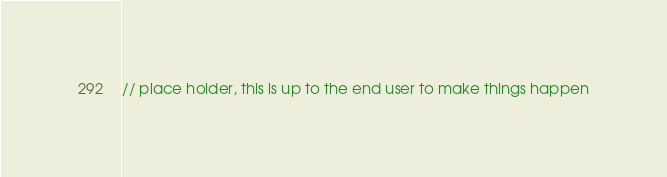Convert code to text. <code><loc_0><loc_0><loc_500><loc_500><_JavaScript_>// place holder, this is up to the end user to make things happen</code> 